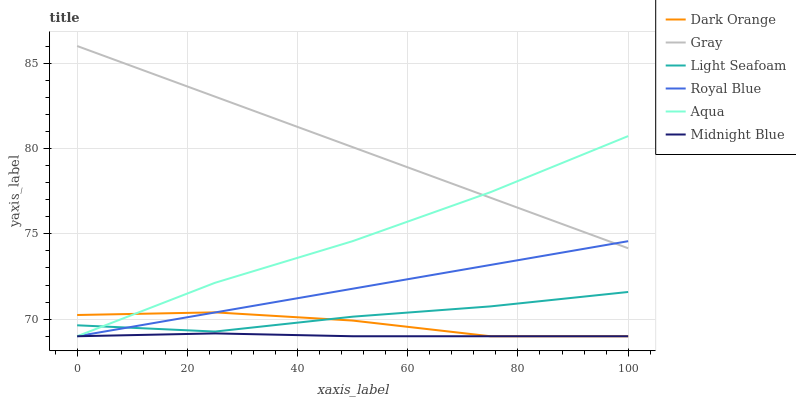Does Gray have the minimum area under the curve?
Answer yes or no. No. Does Midnight Blue have the maximum area under the curve?
Answer yes or no. No. Is Midnight Blue the smoothest?
Answer yes or no. No. Is Midnight Blue the roughest?
Answer yes or no. No. Does Gray have the lowest value?
Answer yes or no. No. Does Midnight Blue have the highest value?
Answer yes or no. No. Is Midnight Blue less than Gray?
Answer yes or no. Yes. Is Gray greater than Dark Orange?
Answer yes or no. Yes. Does Midnight Blue intersect Gray?
Answer yes or no. No. 